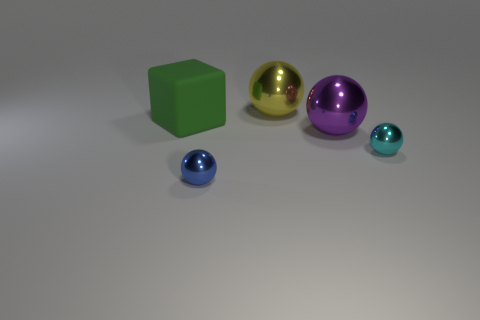Subtract 1 cubes. How many cubes are left? 0 Add 3 green things. How many objects exist? 8 Add 4 green matte objects. How many green matte objects are left? 5 Add 5 brown matte objects. How many brown matte objects exist? 5 Subtract all yellow spheres. How many spheres are left? 3 Subtract all tiny blue balls. How many balls are left? 3 Subtract 0 purple blocks. How many objects are left? 5 Subtract all blocks. How many objects are left? 4 Subtract all gray spheres. Subtract all gray cylinders. How many spheres are left? 4 Subtract all green spheres. How many blue blocks are left? 0 